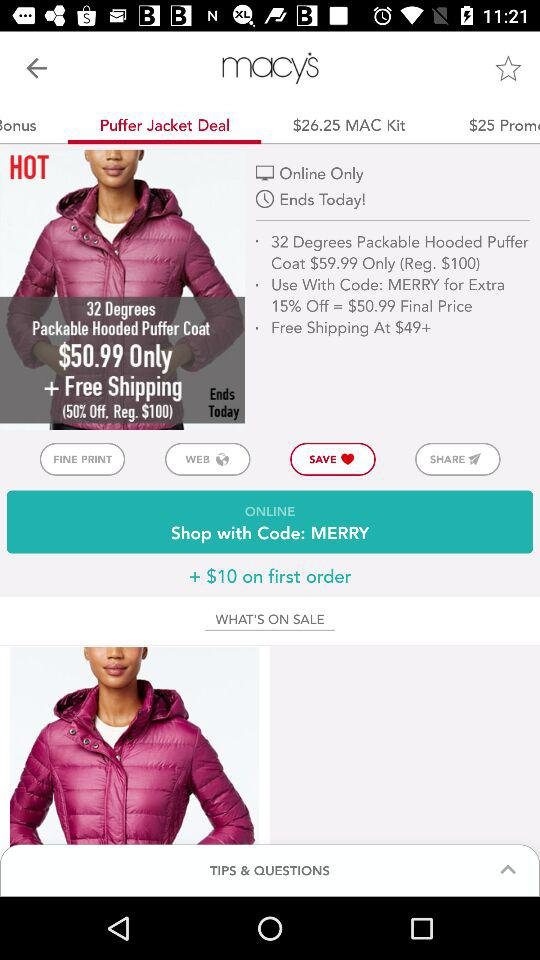What is the shipping charge for the "32 Degrees Packable Puffer Coat"? The shipping is free. 